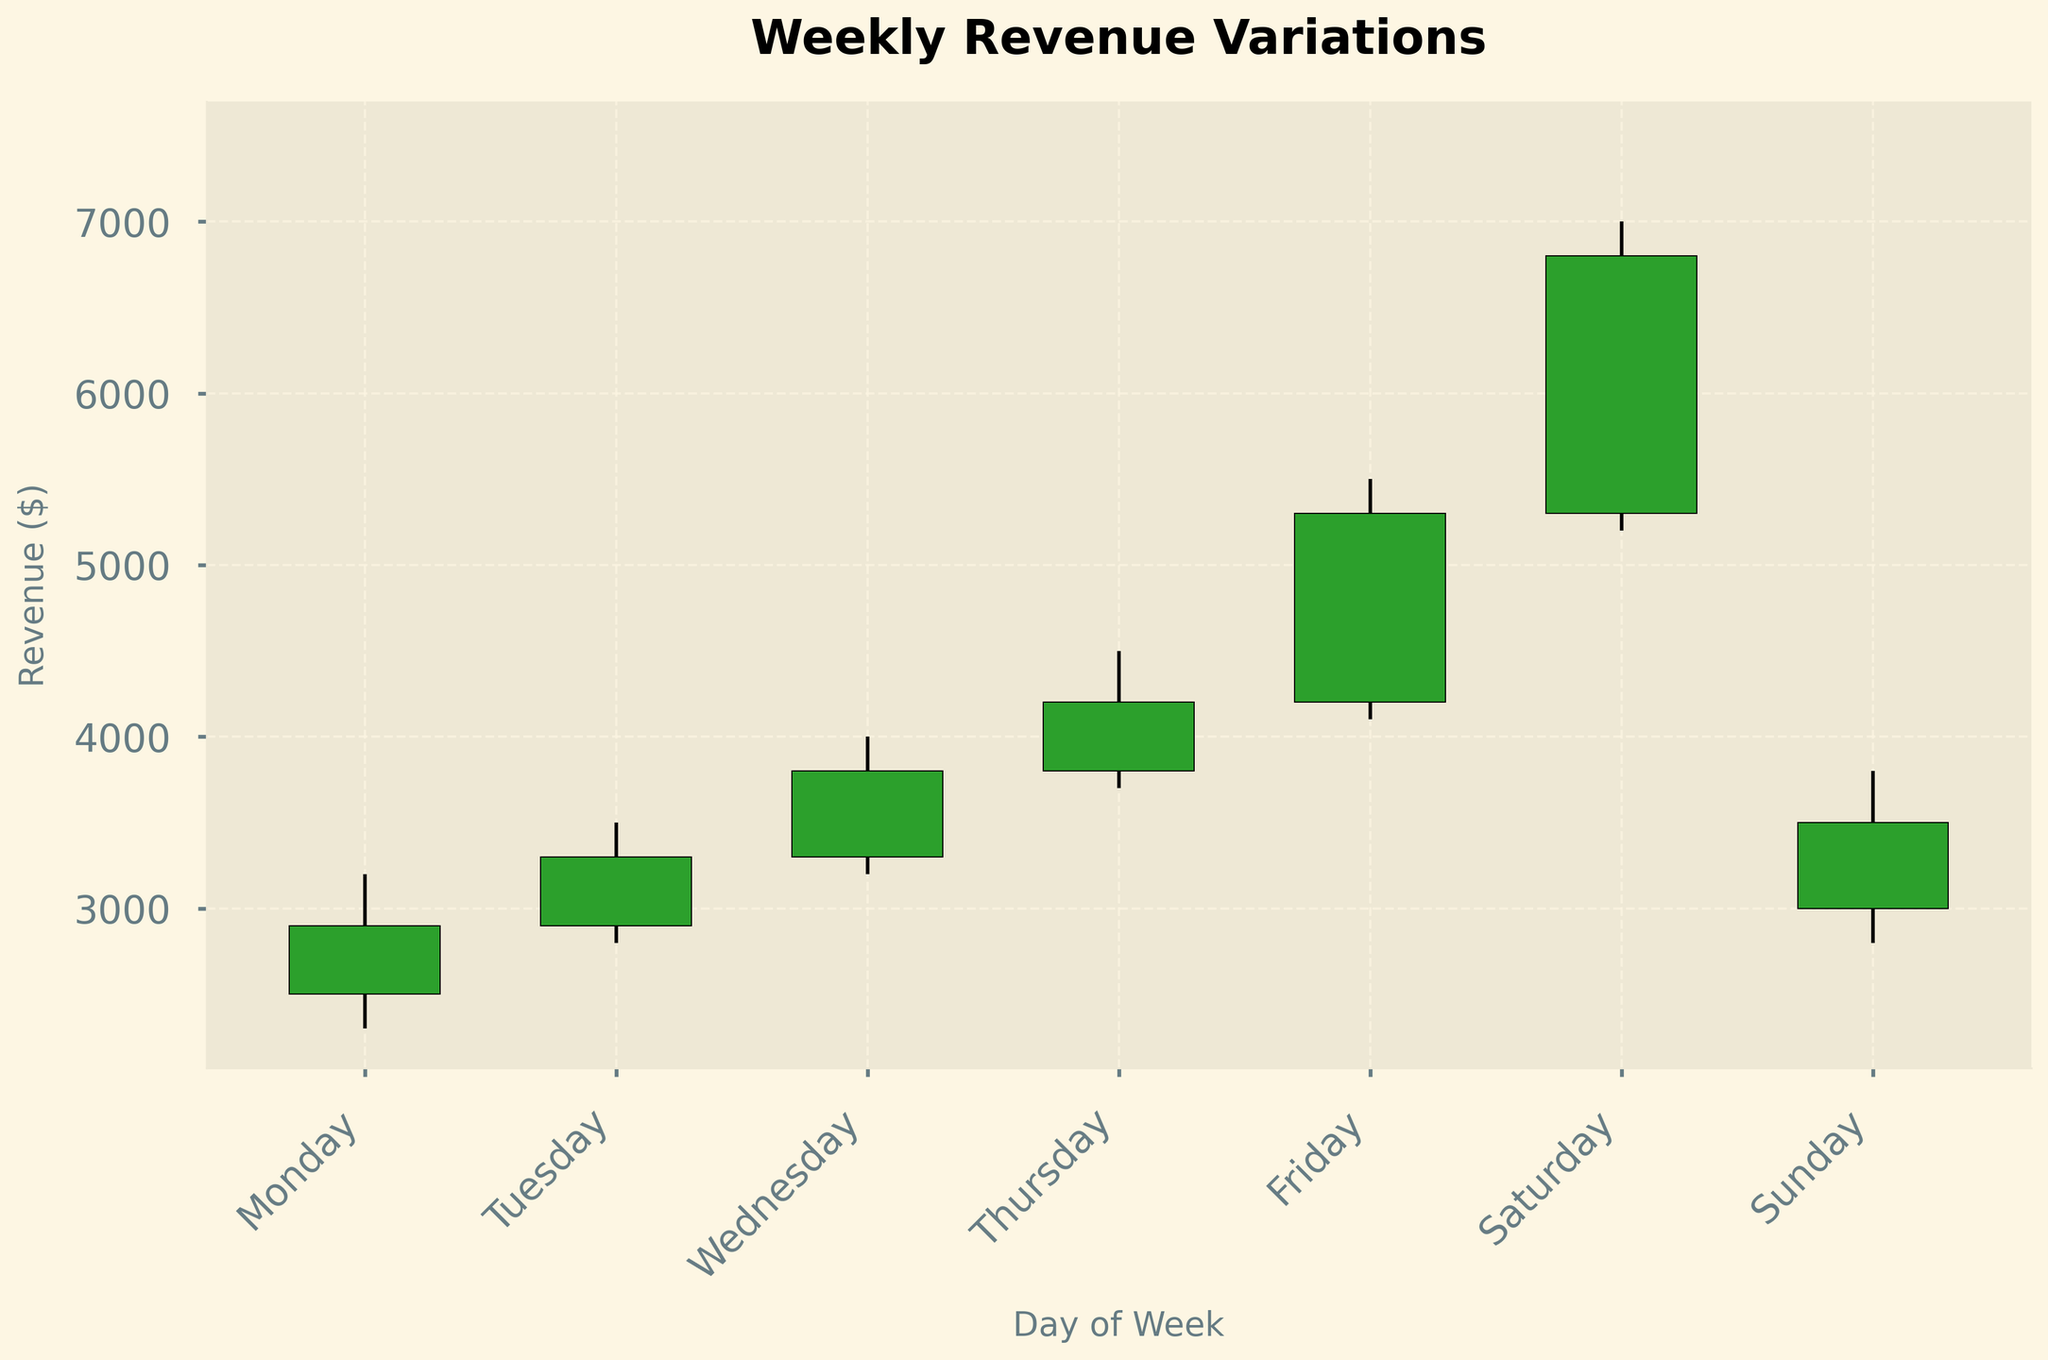What's the title of the figure? The title of the figure is displayed prominently at the top and usually indicates the main subject or purpose of the plot. In this case, it is "Weekly Revenue Variations".
Answer: Weekly Revenue Variations On which day is the highest revenue recorded? The highest revenue is represented by the tallest bar in the figure. By looking at the height of the "High" value, Friday shows a revenue peak at 7000.
Answer: Saturday Which day has the lowest closing revenue? The closing revenue is indicated by the closing (top or bottom of the bar depending on the color). By comparing the closing values, Monday has the lowest, closing at 2900.
Answer: Monday How does the revenue trend change from Monday to Sunday? Analyzing the revenues from Monday to Sunday, there is an upward trend peaking on Saturday, followed by a dip on Sunday. So, the trend starts low, rises toward the weekend, and then decreases.
Answer: Up, then down What's the comparison between the Monday's opening and closing revenue? To compare, we need to check the open and close values for Monday. The opening revenue is 2500, and the closing revenue is 2900, indicating an increase.
Answer: Increase How is the revenue variance on Wednesday compared to Tuesday? Variance can be perceived by the height of the "High" to "Low" difference. On Tuesday, it ranges from 2800 to 3500, while Wednesday varies from 3200 to 4000. Wednesday has a higher variance.
Answer: Higher variance on Wednesday Which day experiences the largest swing in revenue? The swing is calculated by the difference between the high and low values. Saturday has the highest (7000 - 5200 = 1800).
Answer: Saturday On which day does the closing revenue drop compared to its opening revenue? By identifying the bars where the closing value is lower than the opening value, Sunday closes at 3500 compared to opening at 3000.
Answer: None What is the range of revenue on Friday? The range of revenue on a given day is the difference between the high and low values. For Friday, it's (5500 - 4100 = 1400).
Answer: 1400 Which day's revenue is the most stable? Stability can be inferred from the smallest difference between the high and low values. Monday's revenue fluctuates between 2300 and 3200, giving a range of 900, which is the smallest range in comparison.
Answer: Monday 